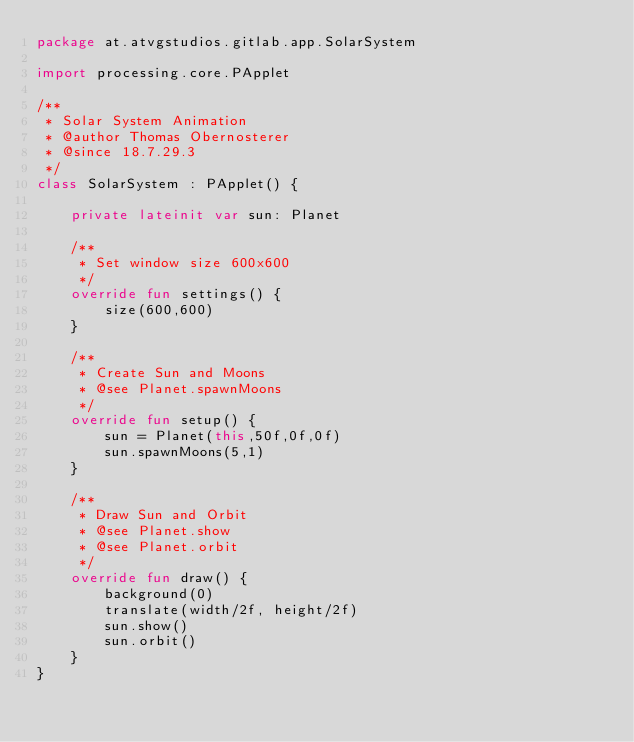Convert code to text. <code><loc_0><loc_0><loc_500><loc_500><_Kotlin_>package at.atvgstudios.gitlab.app.SolarSystem

import processing.core.PApplet

/**
 * Solar System Animation
 * @author Thomas Obernosterer
 * @since 18.7.29.3
 */
class SolarSystem : PApplet() {

    private lateinit var sun: Planet

    /**
     * Set window size 600x600
     */
    override fun settings() {
        size(600,600)
    }

    /**
     * Create Sun and Moons
     * @see Planet.spawnMoons
     */
    override fun setup() {
        sun = Planet(this,50f,0f,0f)
        sun.spawnMoons(5,1)
    }

    /**
     * Draw Sun and Orbit
     * @see Planet.show
     * @see Planet.orbit
     */
    override fun draw() {
        background(0)
        translate(width/2f, height/2f)
        sun.show()
        sun.orbit()
    }
}</code> 